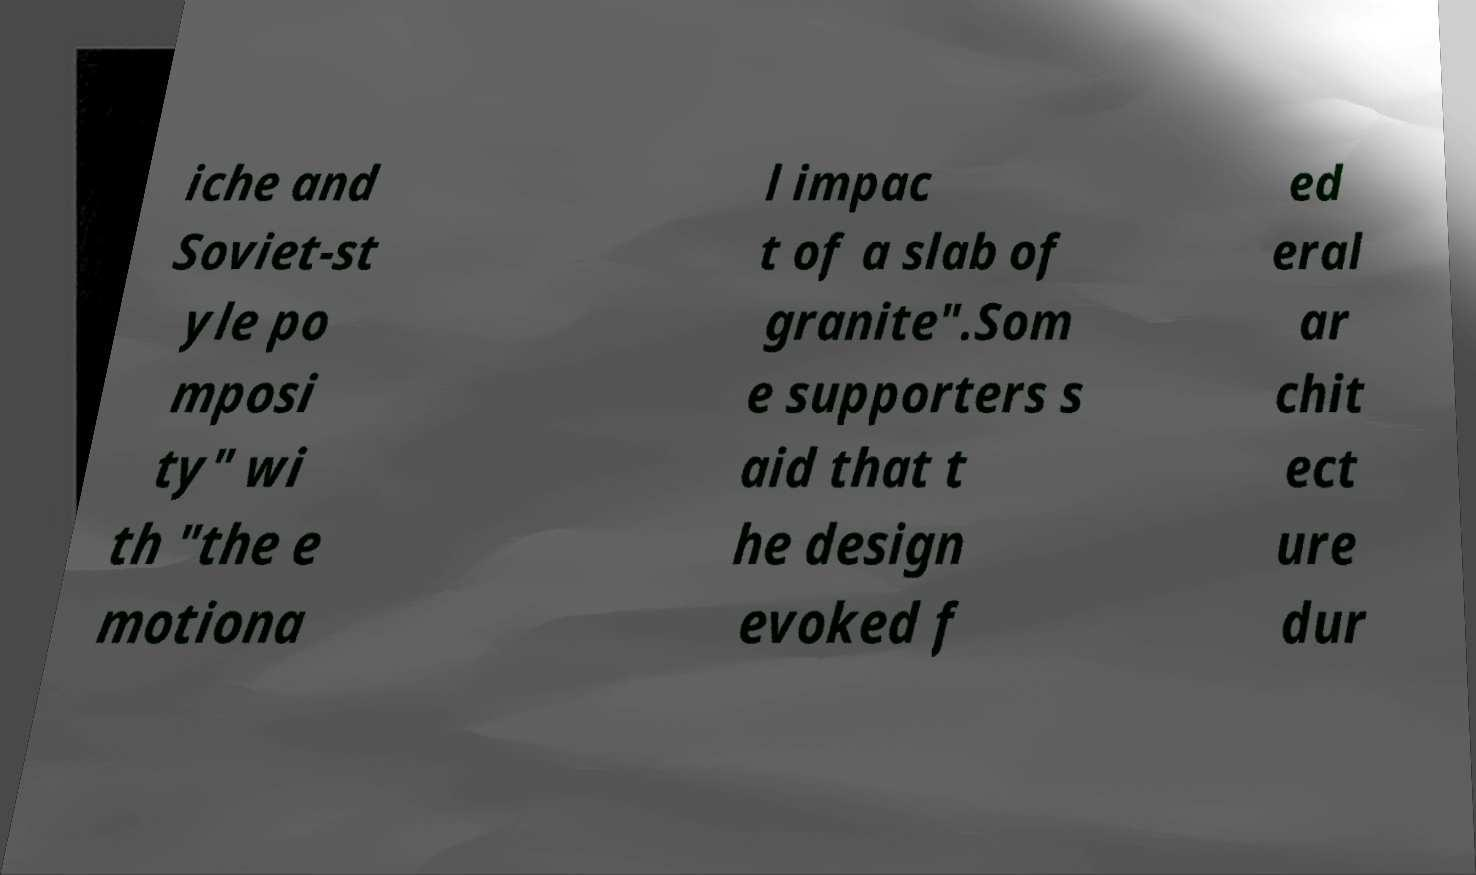Can you read and provide the text displayed in the image?This photo seems to have some interesting text. Can you extract and type it out for me? iche and Soviet-st yle po mposi ty" wi th "the e motiona l impac t of a slab of granite".Som e supporters s aid that t he design evoked f ed eral ar chit ect ure dur 